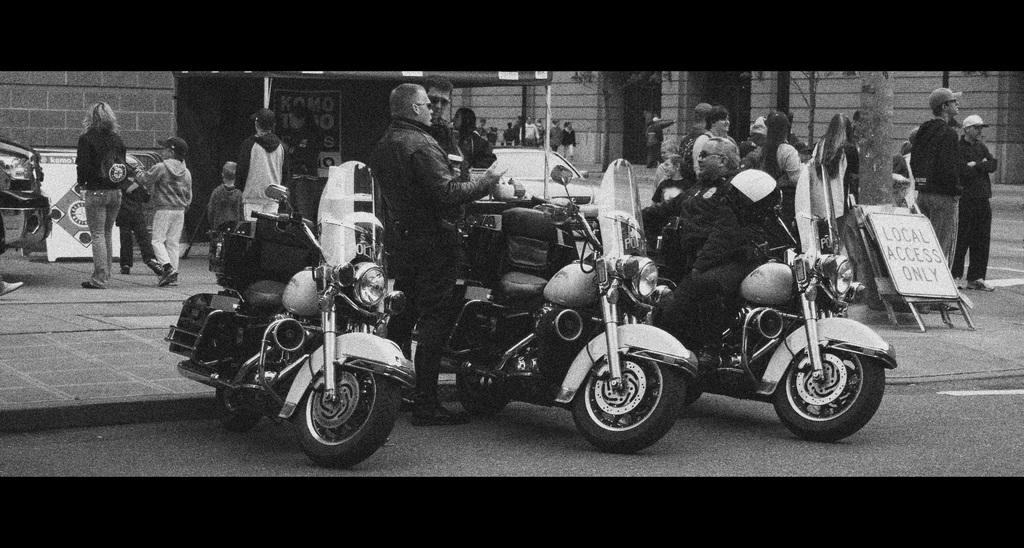What is the color scheme of the image? The image is black and white. What can be seen beside a wall in the image? There is a banner beside a wall in the image. What are the persons in the image doing? The persons are standing in-front of motorbikes in the image. What type of vegetation is present in the image? There is a tree in the image. What is located beside the tree in the image? There is a board beside the tree in the image. How far are the persons from the tree in the image? The persons are standing far from the tree in the image. How many crows are perched on the board beside the tree in the image? There are no crows present in the image; it only features a board beside the tree. What type of deer can be seen grazing near the persons in the image? There are no deer present in the image; it only features persons standing in-front of motorbikes. 